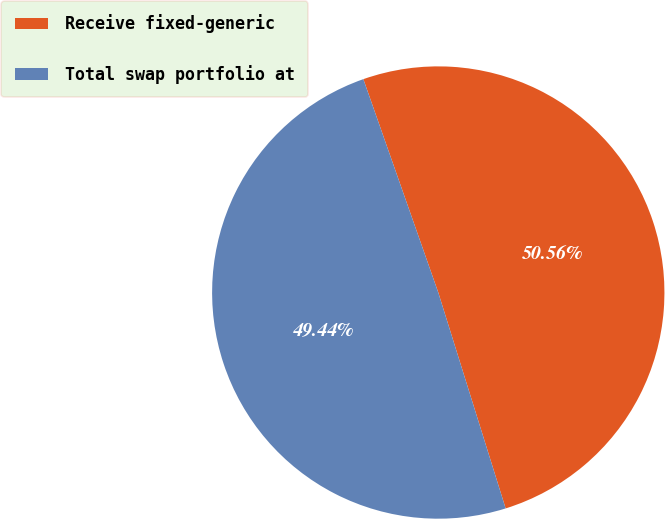<chart> <loc_0><loc_0><loc_500><loc_500><pie_chart><fcel>Receive fixed-generic<fcel>Total swap portfolio at<nl><fcel>50.56%<fcel>49.44%<nl></chart> 